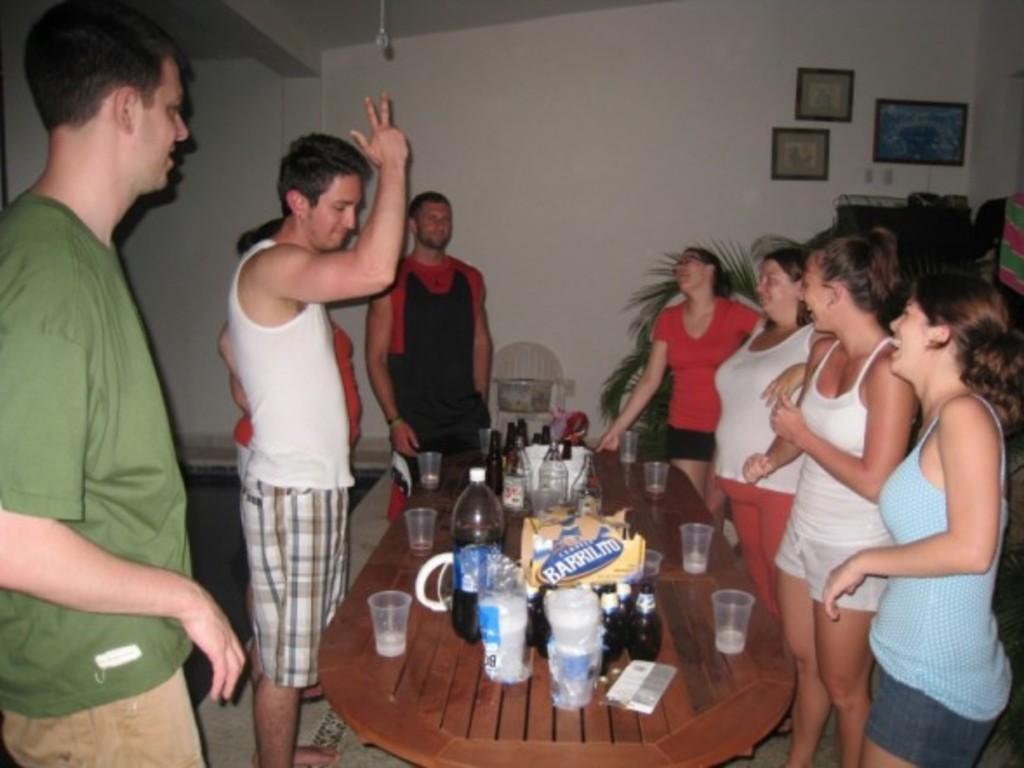Can you describe this image briefly? In this image we can see a group of people standing on the floor. One person is wearing green t shirt. In the foreground we can see a table containing group of glasses, bottles, placed on it. In the background, we can see a plant and photo frames on the wall. 